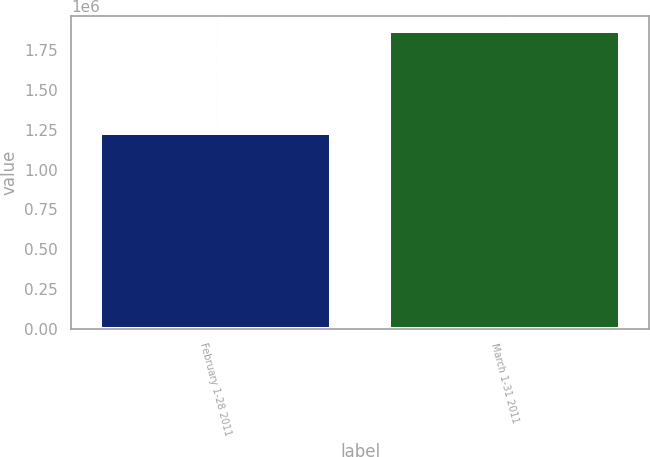Convert chart. <chart><loc_0><loc_0><loc_500><loc_500><bar_chart><fcel>February 1-28 2011<fcel>March 1-31 2011<nl><fcel>1.23124e+06<fcel>1.87279e+06<nl></chart> 